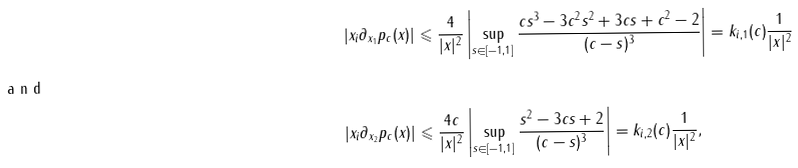<formula> <loc_0><loc_0><loc_500><loc_500>| x _ { i } \partial _ { x _ { 1 } } p _ { c } ( x ) | & \leqslant \frac { 4 } { | x | ^ { 2 } } \left | \sup _ { s \in [ - 1 , 1 ] } \frac { c s ^ { 3 } - 3 c ^ { 2 } s ^ { 2 } + 3 c s + c ^ { 2 } - 2 } { ( c - s ) ^ { 3 } } \right | = k _ { i , 1 } ( c ) \frac { 1 } { | x | ^ { 2 } } \\ \intertext { a n d } | x _ { i } \partial _ { x _ { 2 } } p _ { c } ( x ) | & \leqslant \frac { 4 c } { | x | ^ { 2 } } \left | \sup _ { s \in [ - 1 , 1 ] } \frac { s ^ { 2 } - 3 c s + 2 } { ( c - s ) ^ { 3 } } \right | = k _ { i , 2 } ( c ) \frac { 1 } { | x | ^ { 2 } } ,</formula> 